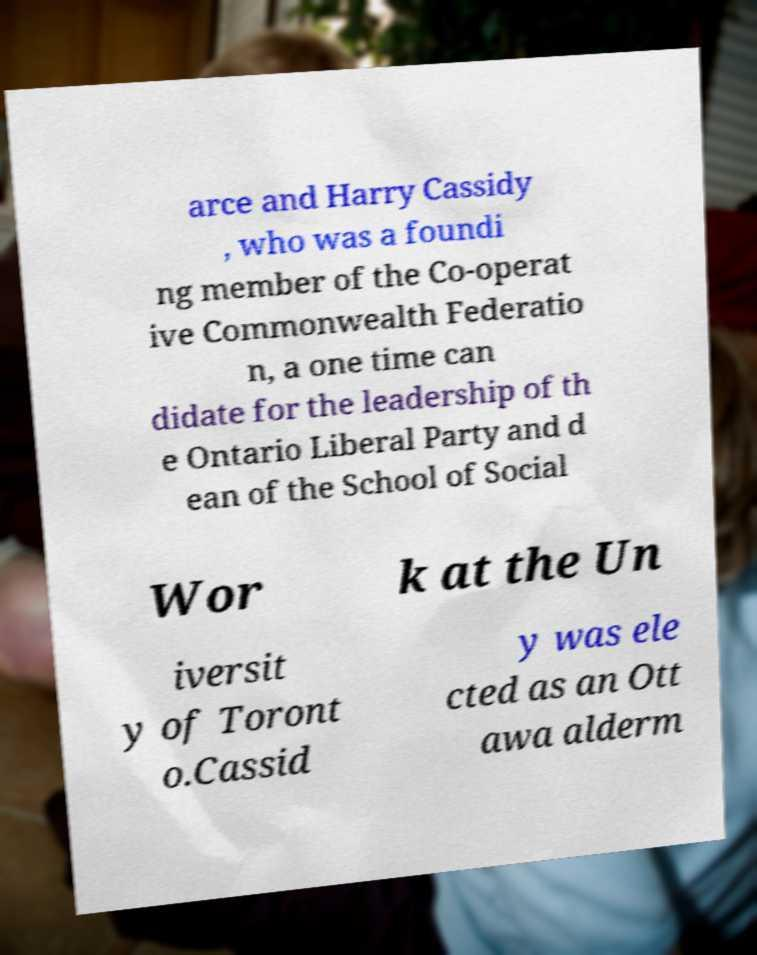Please read and relay the text visible in this image. What does it say? arce and Harry Cassidy , who was a foundi ng member of the Co-operat ive Commonwealth Federatio n, a one time can didate for the leadership of th e Ontario Liberal Party and d ean of the School of Social Wor k at the Un iversit y of Toront o.Cassid y was ele cted as an Ott awa alderm 